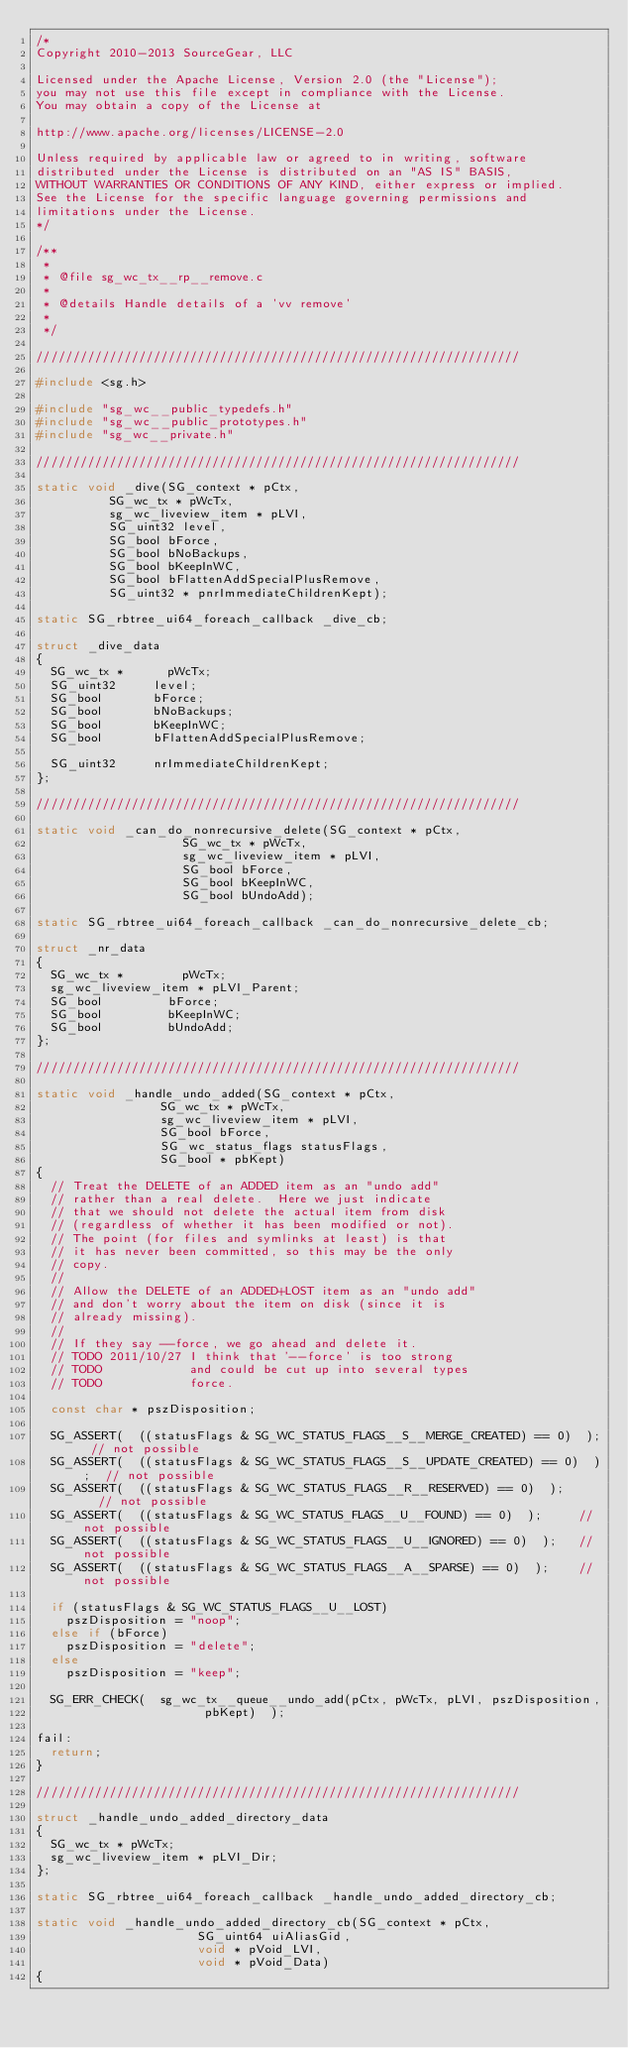<code> <loc_0><loc_0><loc_500><loc_500><_C_>/*
Copyright 2010-2013 SourceGear, LLC

Licensed under the Apache License, Version 2.0 (the "License");
you may not use this file except in compliance with the License.
You may obtain a copy of the License at

http://www.apache.org/licenses/LICENSE-2.0

Unless required by applicable law or agreed to in writing, software
distributed under the License is distributed on an "AS IS" BASIS,
WITHOUT WARRANTIES OR CONDITIONS OF ANY KIND, either express or implied.
See the License for the specific language governing permissions and
limitations under the License.
*/

/**
 *
 * @file sg_wc_tx__rp__remove.c
 *
 * @details Handle details of a 'vv remove'
 *
 */

//////////////////////////////////////////////////////////////////

#include <sg.h>

#include "sg_wc__public_typedefs.h"
#include "sg_wc__public_prototypes.h"
#include "sg_wc__private.h"

//////////////////////////////////////////////////////////////////

static void _dive(SG_context * pCtx,
				  SG_wc_tx * pWcTx,
				  sg_wc_liveview_item * pLVI,
				  SG_uint32 level,
				  SG_bool bForce,
				  SG_bool bNoBackups,
				  SG_bool bKeepInWC,
				  SG_bool bFlattenAddSpecialPlusRemove,
				  SG_uint32 * pnrImmediateChildrenKept);

static SG_rbtree_ui64_foreach_callback _dive_cb;

struct _dive_data
{
	SG_wc_tx *			pWcTx;
	SG_uint32			level;
	SG_bool				bForce;
	SG_bool				bNoBackups;
	SG_bool				bKeepInWC;
	SG_bool				bFlattenAddSpecialPlusRemove;

	SG_uint32			nrImmediateChildrenKept;
};

//////////////////////////////////////////////////////////////////

static void _can_do_nonrecursive_delete(SG_context * pCtx,
										SG_wc_tx * pWcTx,
										sg_wc_liveview_item * pLVI,
										SG_bool bForce,
										SG_bool bKeepInWC,
										SG_bool bUndoAdd);

static SG_rbtree_ui64_foreach_callback _can_do_nonrecursive_delete_cb;

struct _nr_data
{
	SG_wc_tx *				pWcTx;
	sg_wc_liveview_item *	pLVI_Parent;
	SG_bool					bForce;
	SG_bool					bKeepInWC;
	SG_bool					bUndoAdd;
};

//////////////////////////////////////////////////////////////////

static void _handle_undo_added(SG_context * pCtx,
							   SG_wc_tx * pWcTx,
							   sg_wc_liveview_item * pLVI,
							   SG_bool bForce,
							   SG_wc_status_flags statusFlags,
							   SG_bool * pbKept)
{
	// Treat the DELETE of an ADDED item as an "undo add"
	// rather than a real delete.  Here we just indicate
	// that we should not delete the actual item from disk
	// (regardless of whether it has been modified or not).
	// The point (for files and symlinks at least) is that
	// it has never been committed, so this may be the only
	// copy.
	//
	// Allow the DELETE of an ADDED+LOST item as an "undo add"
	// and don't worry about the item on disk (since it is
	// already missing).
	// 
	// If they say --force, we go ahead and delete it.
	// TODO 2011/10/27 I think that '--force' is too strong
	// TODO            and could be cut up into several types
	// TODO            force.

	const char * pszDisposition;

	SG_ASSERT(  ((statusFlags & SG_WC_STATUS_FLAGS__S__MERGE_CREATED) == 0)  );	// not possible
	SG_ASSERT(  ((statusFlags & SG_WC_STATUS_FLAGS__S__UPDATE_CREATED) == 0)  );	// not possible
	SG_ASSERT(  ((statusFlags & SG_WC_STATUS_FLAGS__R__RESERVED) == 0)  );			// not possible
	SG_ASSERT(  ((statusFlags & SG_WC_STATUS_FLAGS__U__FOUND) == 0)  );			// not possible
	SG_ASSERT(  ((statusFlags & SG_WC_STATUS_FLAGS__U__IGNORED) == 0)  );		// not possible
	SG_ASSERT(  ((statusFlags & SG_WC_STATUS_FLAGS__A__SPARSE) == 0)  );		// not possible

	if (statusFlags & SG_WC_STATUS_FLAGS__U__LOST)
		pszDisposition = "noop";
	else if (bForce)
		pszDisposition = "delete";
	else
		pszDisposition = "keep";

	SG_ERR_CHECK(  sg_wc_tx__queue__undo_add(pCtx, pWcTx, pLVI, pszDisposition,
											 pbKept)  );

fail:
	return;
}

//////////////////////////////////////////////////////////////////

struct _handle_undo_added_directory_data
{
	SG_wc_tx * pWcTx;
	sg_wc_liveview_item * pLVI_Dir;
};

static SG_rbtree_ui64_foreach_callback _handle_undo_added_directory_cb;

static void _handle_undo_added_directory_cb(SG_context * pCtx,
											SG_uint64 uiAliasGid,
											void * pVoid_LVI,
											void * pVoid_Data)
{</code> 